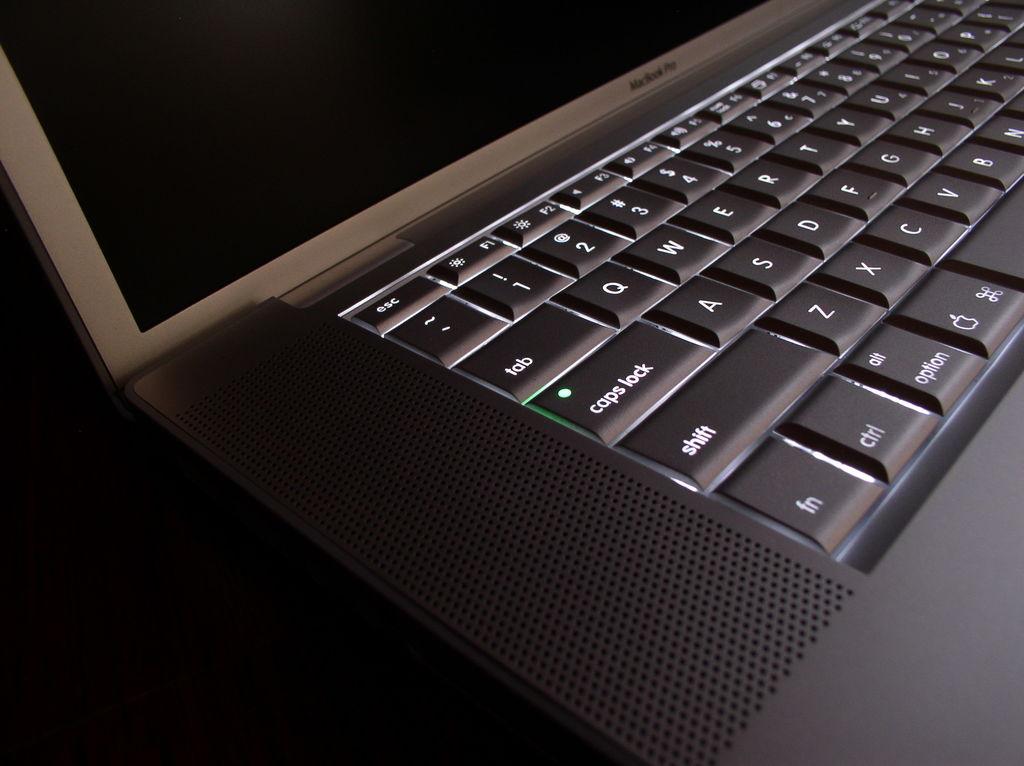What brand is thelaptop?
Provide a succinct answer. Macbook pro. What does the key say that has a green light on it?
Ensure brevity in your answer.  Caps lock. 